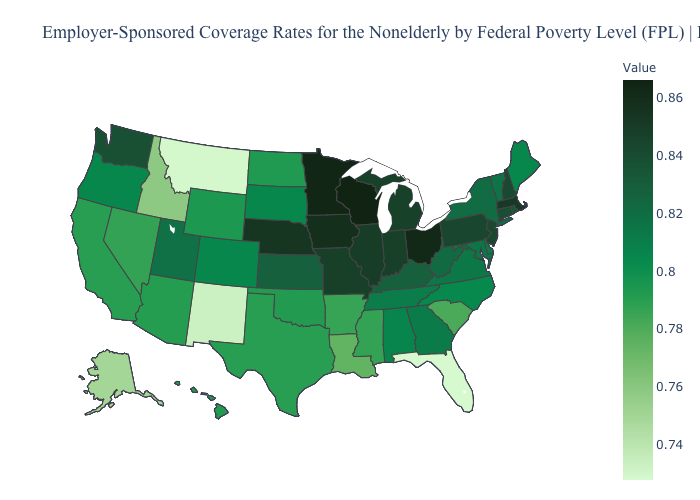Among the states that border Mississippi , which have the lowest value?
Quick response, please. Louisiana. Which states have the highest value in the USA?
Short answer required. Wisconsin. Which states have the lowest value in the USA?
Answer briefly. Florida. Among the states that border Kentucky , which have the lowest value?
Be succinct. Tennessee. Which states have the highest value in the USA?
Quick response, please. Wisconsin. Does Wisconsin have the highest value in the USA?
Quick response, please. Yes. 